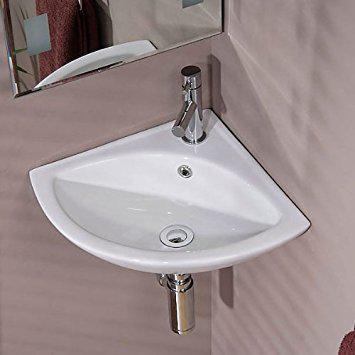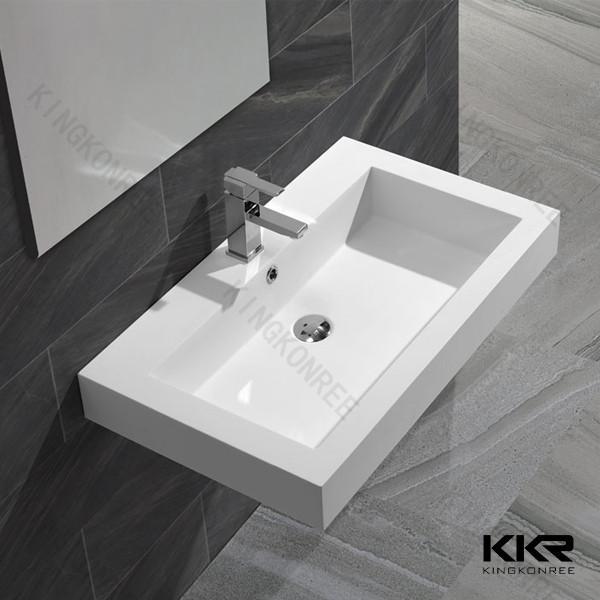The first image is the image on the left, the second image is the image on the right. Considering the images on both sides, is "The sink on the left fits in a corner, and the sink on the right includes a spout mounted to a rectangular white component." valid? Answer yes or no. Yes. 